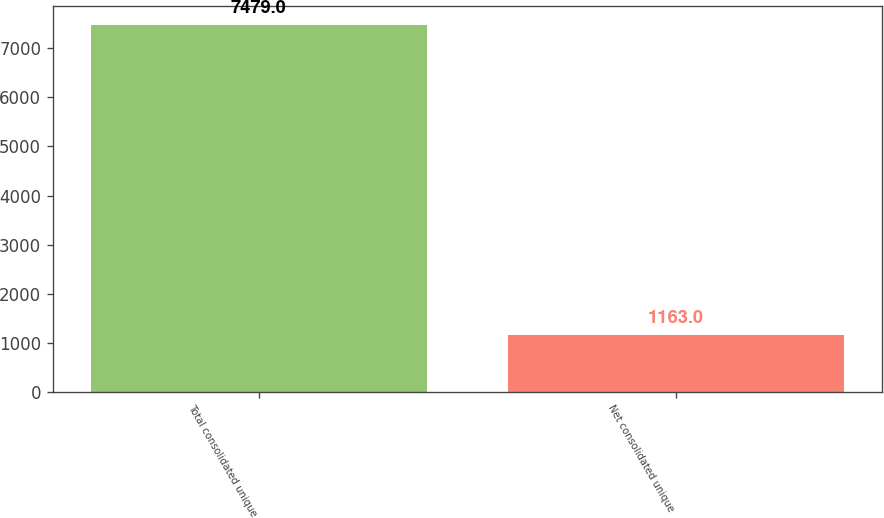Convert chart to OTSL. <chart><loc_0><loc_0><loc_500><loc_500><bar_chart><fcel>Total consolidated unique<fcel>Net consolidated unique<nl><fcel>7479<fcel>1163<nl></chart> 